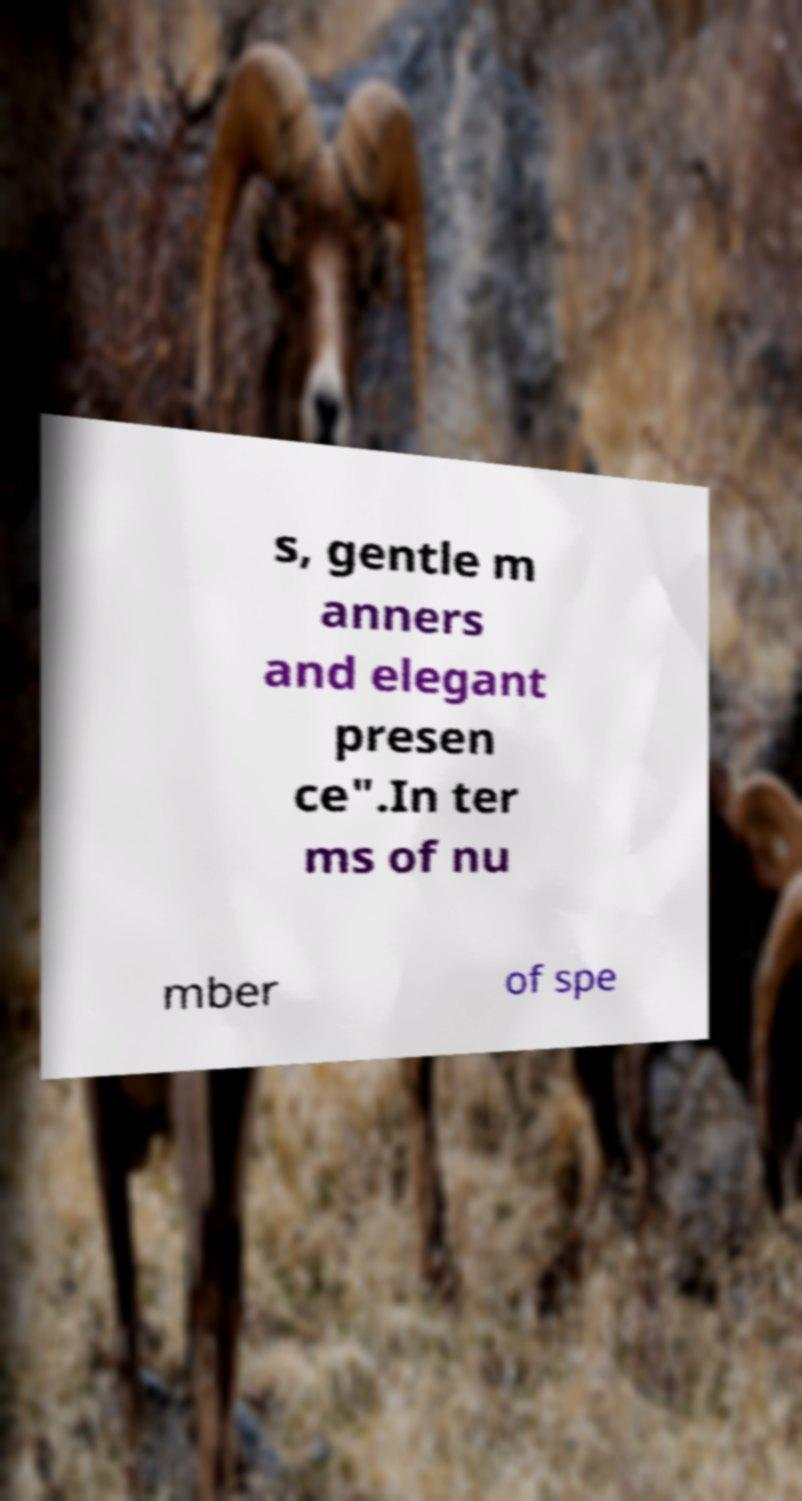Can you read and provide the text displayed in the image?This photo seems to have some interesting text. Can you extract and type it out for me? s, gentle m anners and elegant presen ce".In ter ms of nu mber of spe 